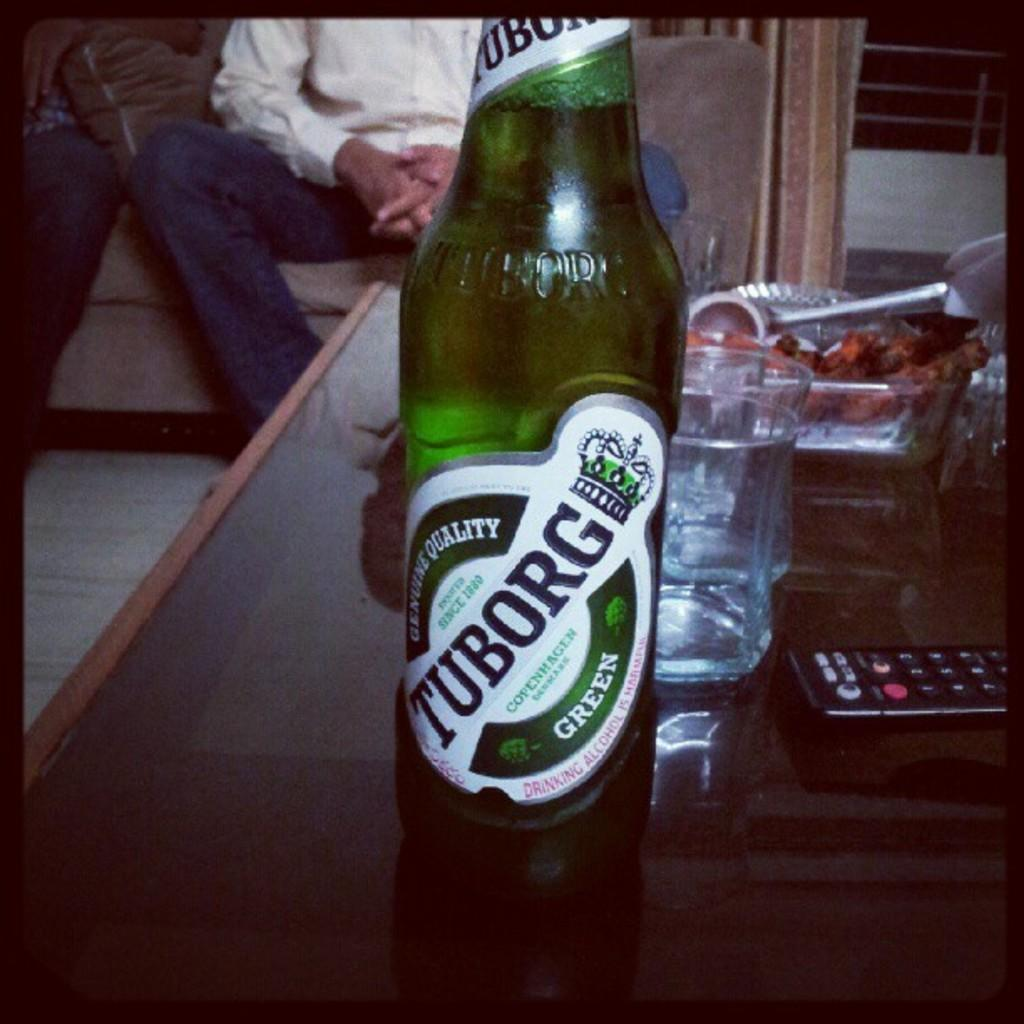Provide a one-sentence caption for the provided image. A green bottle of Tuborg beer sits on a coffee table. 